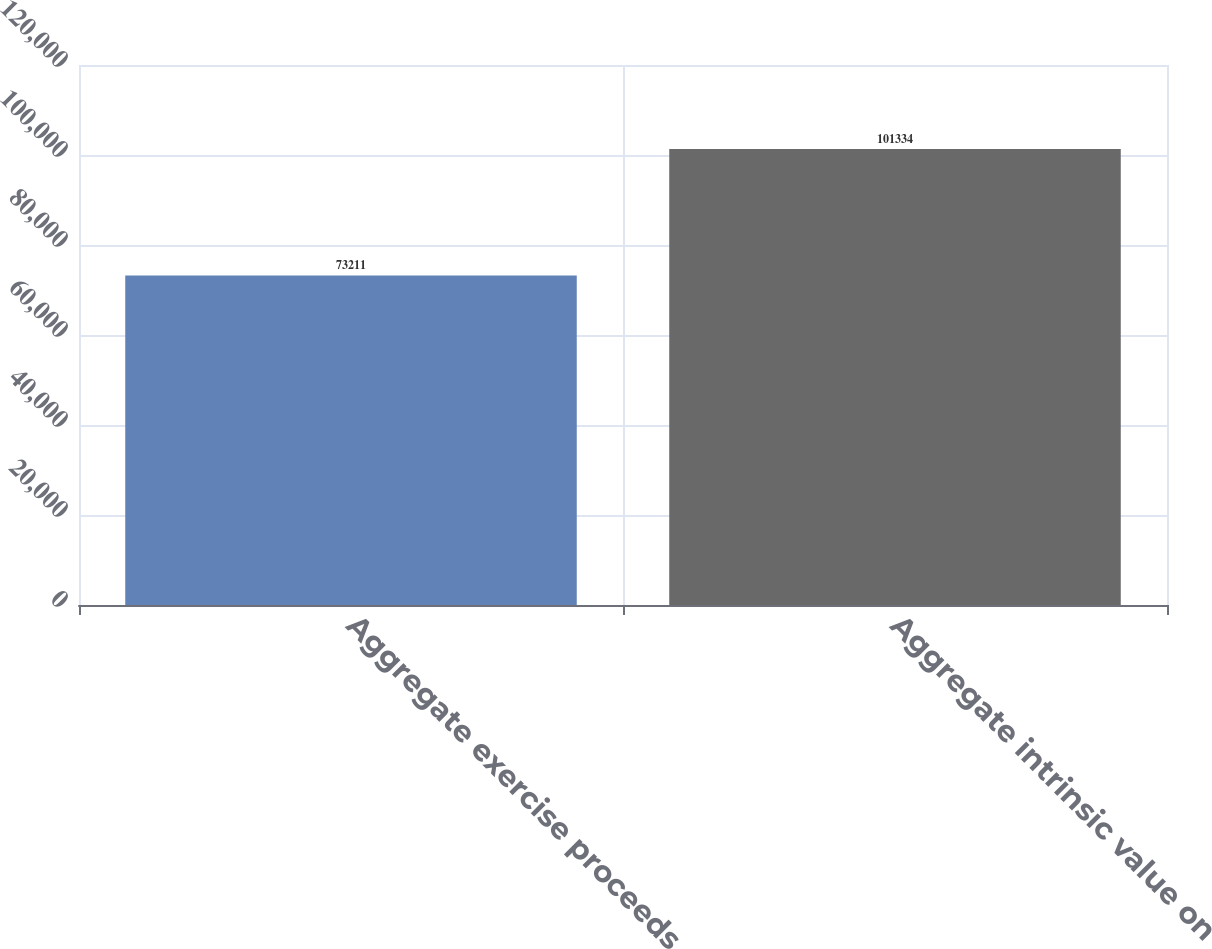<chart> <loc_0><loc_0><loc_500><loc_500><bar_chart><fcel>Aggregate exercise proceeds<fcel>Aggregate intrinsic value on<nl><fcel>73211<fcel>101334<nl></chart> 